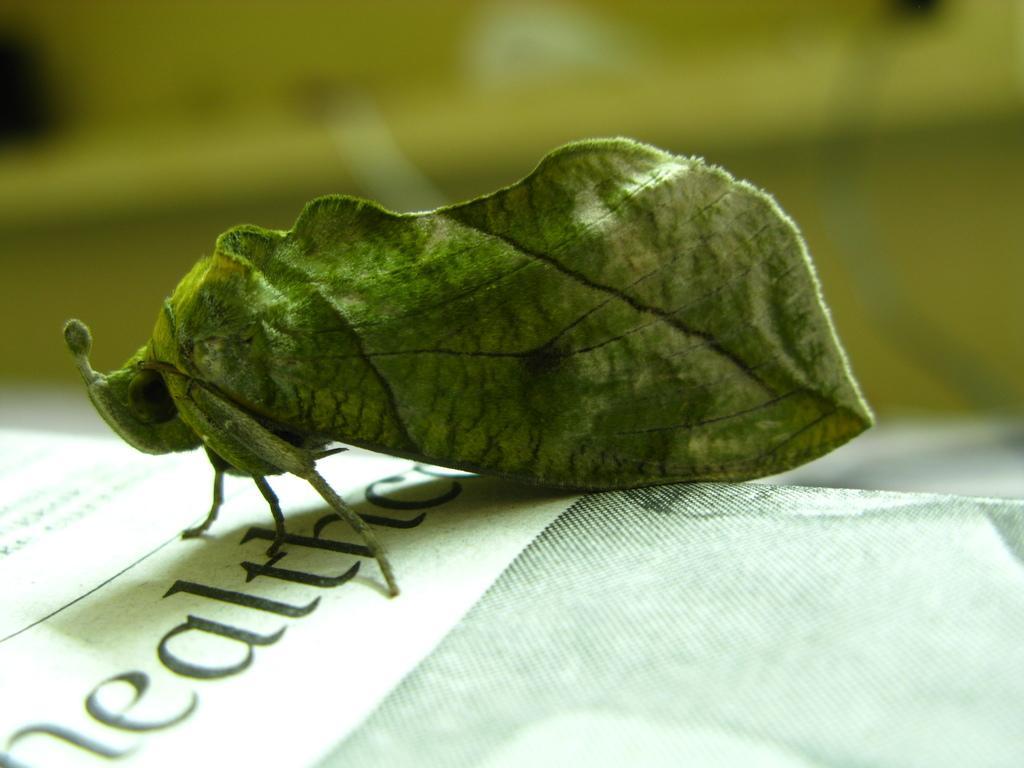Describe this image in one or two sentences. In this image, in the middle there is an insect. At the bottom there is a poster. 